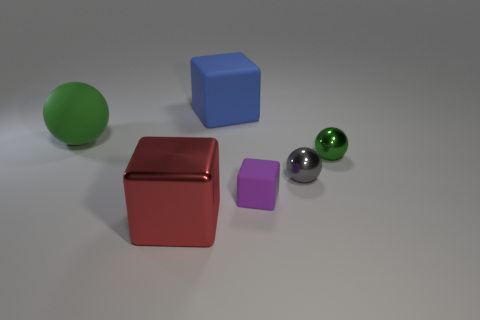Are there any other things that are the same color as the rubber ball?
Offer a very short reply. Yes. What is the color of the block that is to the left of the matte cube that is behind the green metallic object?
Ensure brevity in your answer.  Red. Is the number of tiny gray metal objects that are in front of the shiny cube less than the number of blue blocks left of the big rubber block?
Your answer should be compact. No. What is the material of the tiny thing that is the same color as the big sphere?
Your answer should be very brief. Metal. How many things are either shiny spheres in front of the small green object or big rubber objects?
Ensure brevity in your answer.  3. Do the green sphere to the left of the purple object and the purple matte object have the same size?
Offer a terse response. No. Are there fewer large red things on the right side of the big red shiny thing than large blue cylinders?
Your response must be concise. No. There is a green object that is the same size as the purple object; what is its material?
Ensure brevity in your answer.  Metal. How many large things are green metal spheres or brown shiny cubes?
Offer a terse response. 0. How many things are matte blocks on the right side of the big blue matte object or objects in front of the tiny purple block?
Your answer should be very brief. 2. 